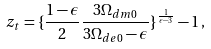Convert formula to latex. <formula><loc_0><loc_0><loc_500><loc_500>z _ { t } = \{ \frac { 1 - \epsilon } { 2 } \frac { 3 \Omega _ { d m 0 } } { 3 \Omega _ { d e 0 } - \epsilon } \} ^ { \frac { 1 } { \epsilon - 3 } } - 1 \, ,</formula> 